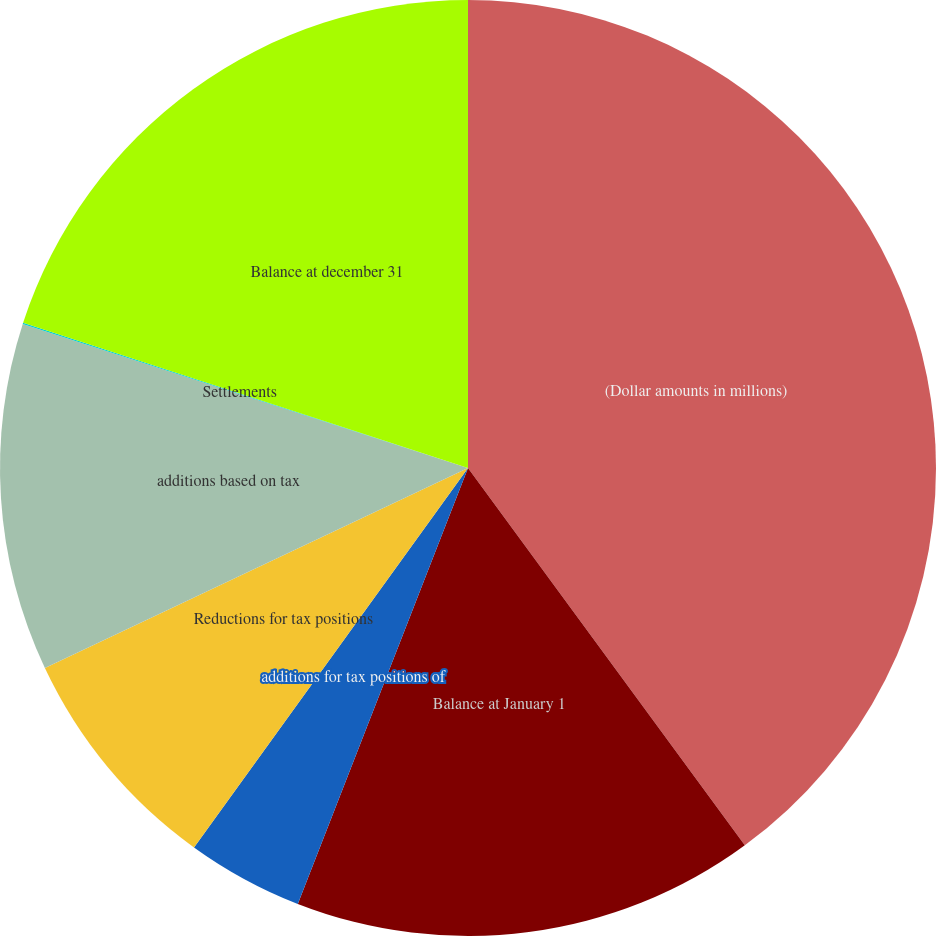Convert chart to OTSL. <chart><loc_0><loc_0><loc_500><loc_500><pie_chart><fcel>(Dollar amounts in millions)<fcel>Balance at January 1<fcel>additions for tax positions of<fcel>Reductions for tax positions<fcel>additions based on tax<fcel>Settlements<fcel>Balance at december 31<nl><fcel>39.93%<fcel>16.0%<fcel>4.03%<fcel>8.02%<fcel>12.01%<fcel>0.04%<fcel>19.98%<nl></chart> 